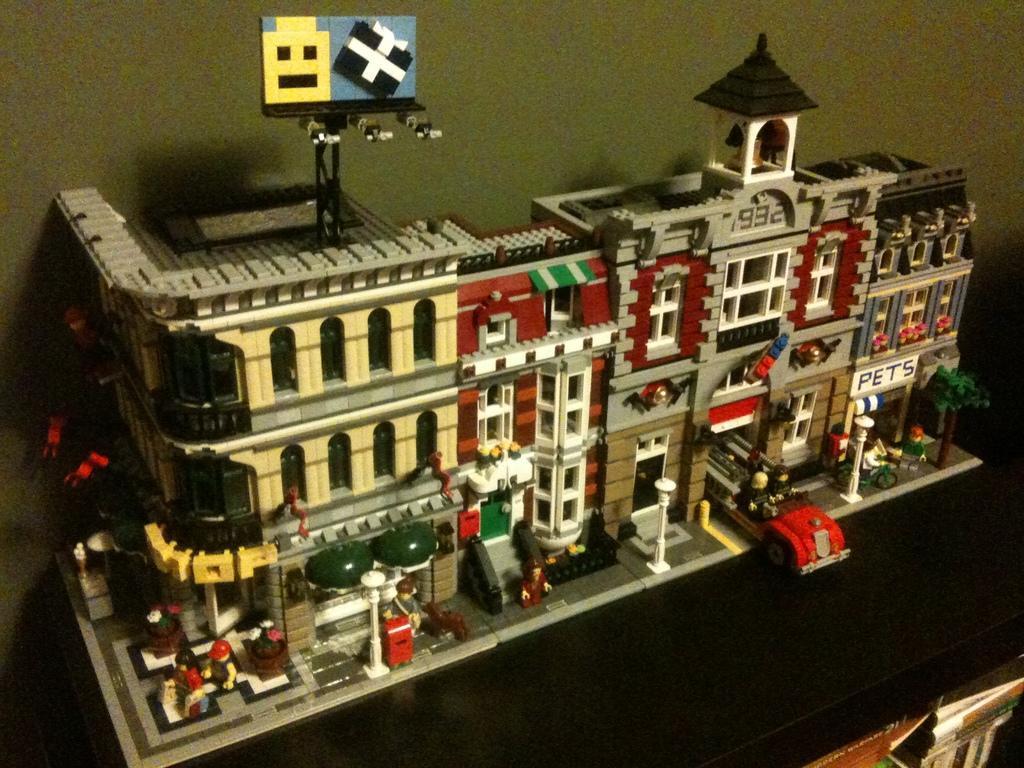In one or two sentences, can you explain what this image depicts? In this image we can see a model of a building on the black color surface. We can see books in the right bottom of the image. In the background, there is a wall. 